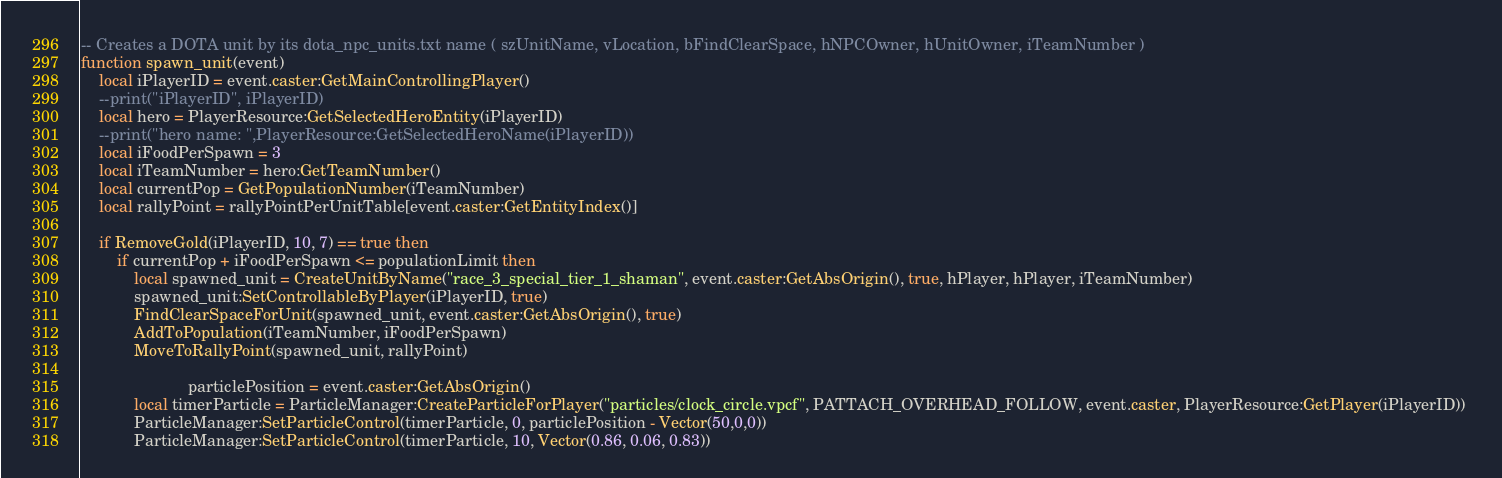Convert code to text. <code><loc_0><loc_0><loc_500><loc_500><_Lua_>-- Creates a DOTA unit by its dota_npc_units.txt name ( szUnitName, vLocation, bFindClearSpace, hNPCOwner, hUnitOwner, iTeamNumber )
function spawn_unit(event)
	local iPlayerID = event.caster:GetMainControllingPlayer()
	--print("iPlayerID", iPlayerID)
	local hero = PlayerResource:GetSelectedHeroEntity(iPlayerID)
	--print("hero name: ",PlayerResource:GetSelectedHeroName(iPlayerID))
	local iFoodPerSpawn = 3
	local iTeamNumber = hero:GetTeamNumber()
	local currentPop = GetPopulationNumber(iTeamNumber)
	local rallyPoint = rallyPointPerUnitTable[event.caster:GetEntityIndex()]
	
	if RemoveGold(iPlayerID, 10, 7) == true then
		if currentPop + iFoodPerSpawn <= populationLimit then
			local spawned_unit = CreateUnitByName("race_3_special_tier_1_shaman", event.caster:GetAbsOrigin(), true, hPlayer, hPlayer, iTeamNumber)
			spawned_unit:SetControllableByPlayer(iPlayerID, true)
			FindClearSpaceForUnit(spawned_unit, event.caster:GetAbsOrigin(), true)
			AddToPopulation(iTeamNumber, iFoodPerSpawn)
			MoveToRallyPoint(spawned_unit, rallyPoint)

						particlePosition = event.caster:GetAbsOrigin()
			local timerParticle = ParticleManager:CreateParticleForPlayer("particles/clock_circle.vpcf", PATTACH_OVERHEAD_FOLLOW, event.caster, PlayerResource:GetPlayer(iPlayerID)) 
			ParticleManager:SetParticleControl(timerParticle, 0, particlePosition - Vector(50,0,0))
			ParticleManager:SetParticleControl(timerParticle, 10, Vector(0.86, 0.06, 0.83))
</code> 